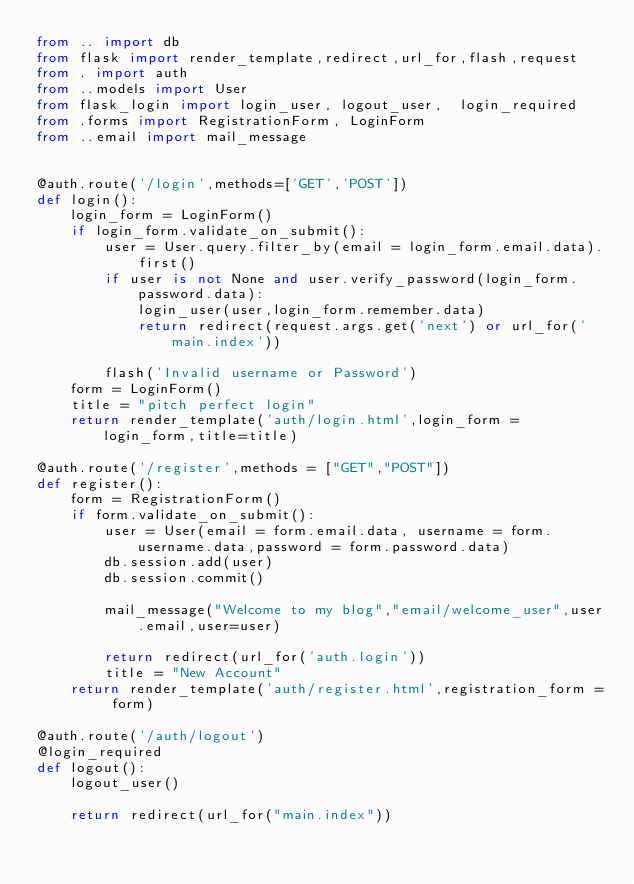Convert code to text. <code><loc_0><loc_0><loc_500><loc_500><_Python_>from .. import db
from flask import render_template,redirect,url_for,flash,request
from . import auth
from ..models import User  
from flask_login import login_user, logout_user,  login_required
from .forms import RegistrationForm, LoginForm
from ..email import mail_message


@auth.route('/login',methods=['GET','POST'])
def login():
    login_form = LoginForm()
    if login_form.validate_on_submit():
        user = User.query.filter_by(email = login_form.email.data).first()
        if user is not None and user.verify_password(login_form.password.data):
            login_user(user,login_form.remember.data)
            return redirect(request.args.get('next') or url_for('main.index'))

        flash('Invalid username or Password')
    form = LoginForm()
    title = "pitch perfect login"
    return render_template('auth/login.html',login_form = login_form,title=title)

@auth.route('/register',methods = ["GET","POST"])
def register():
    form = RegistrationForm()
    if form.validate_on_submit():
        user = User(email = form.email.data, username = form.username.data,password = form.password.data)
        db.session.add(user)
        db.session.commit()

        mail_message("Welcome to my blog","email/welcome_user",user.email,user=user)

        return redirect(url_for('auth.login'))
        title = "New Account"
    return render_template('auth/register.html',registration_form = form)

@auth.route('/auth/logout')
@login_required
def logout():
    logout_user()
    
    return redirect(url_for("main.index"))</code> 